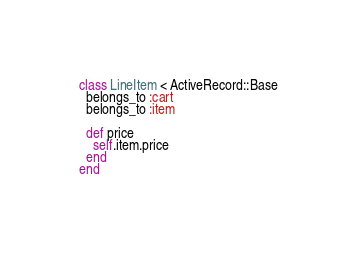Convert code to text. <code><loc_0><loc_0><loc_500><loc_500><_Ruby_>class LineItem < ActiveRecord::Base
  belongs_to :cart
  belongs_to :item

  def price
    self.item.price
  end
end
</code> 